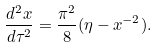<formula> <loc_0><loc_0><loc_500><loc_500>\frac { d ^ { 2 } x } { d \tau ^ { 2 } } = \frac { \pi ^ { 2 } } { 8 } ( \eta - x ^ { - 2 } ) .</formula> 